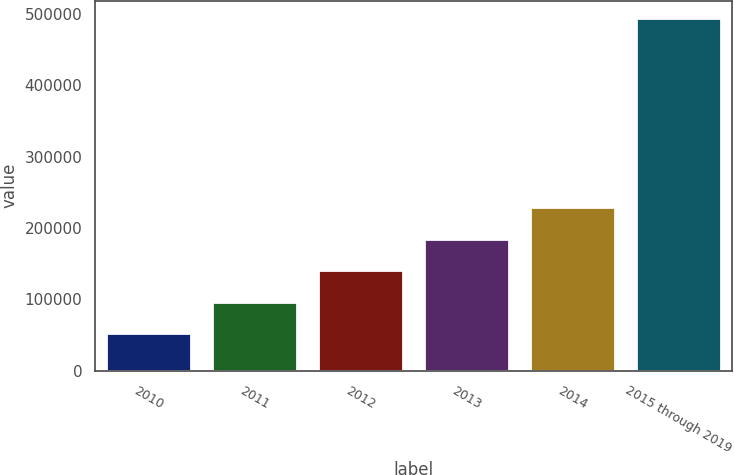Convert chart to OTSL. <chart><loc_0><loc_0><loc_500><loc_500><bar_chart><fcel>2010<fcel>2011<fcel>2012<fcel>2013<fcel>2014<fcel>2015 through 2019<nl><fcel>52842<fcel>96924.9<fcel>141008<fcel>185091<fcel>229174<fcel>493671<nl></chart> 